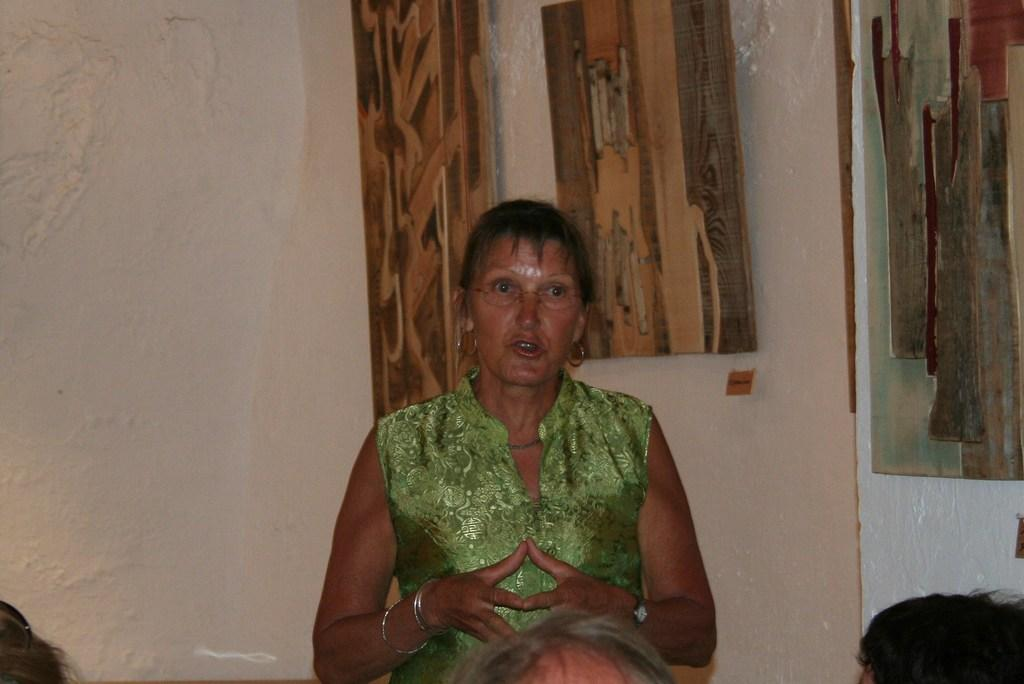What is the color of the wall in the image? There is a white color wall in the image. Can you describe the people in the image? There are people in the image, but their specific characteristics are not mentioned in the facts. What is the woman wearing in the image? A woman is wearing a green color dress in the image. What language is being spoken by the people in the image? The facts provided do not mention any language being spoken by the people in the image. Is there a lake visible in the image? There is no mention of a lake in the image; the facts only mention a white color wall, people, and a woman wearing a green color dress. 